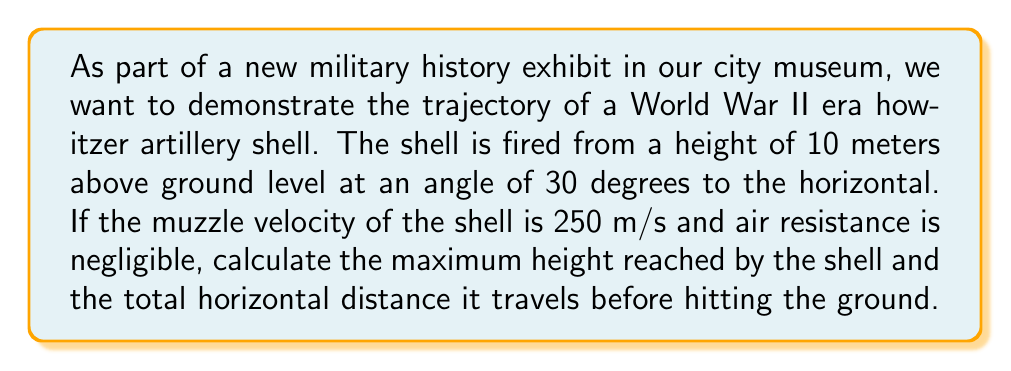Could you help me with this problem? Let's approach this problem step by step using projectile motion equations.

1) First, let's define our variables:
   $v_0 = 250$ m/s (initial velocity)
   $\theta = 30°$ (angle of projection)
   $g = 9.8$ m/s² (acceleration due to gravity)
   $y_0 = 10$ m (initial height)

2) We can break down the initial velocity into its horizontal and vertical components:
   $v_{0x} = v_0 \cos \theta = 250 \cos 30° = 250 \cdot \frac{\sqrt{3}}{2} \approx 216.51$ m/s
   $v_{0y} = v_0 \sin \theta = 250 \sin 30° = 250 \cdot \frac{1}{2} = 125$ m/s

3) To find the maximum height, we need to calculate the time it takes for the vertical velocity to become zero:
   $v_y = v_{0y} - gt$
   $0 = 125 - 9.8t$
   $t = \frac{125}{9.8} \approx 12.76$ seconds

4) Now we can calculate the maximum height using the equation:
   $y = y_0 + v_{0y}t - \frac{1}{2}gt^2$
   $y_{max} = 10 + 125 \cdot 12.76 - \frac{1}{2} \cdot 9.8 \cdot 12.76^2$
   $y_{max} = 10 + 1595 - 796.5 = 808.5$ meters

5) To find the total horizontal distance, we need to calculate the time it takes for the shell to hit the ground. We can use the quadratic formula with the vertical motion equation:
   $y = y_0 + v_{0y}t - \frac{1}{2}gt^2$
   $0 = 10 + 125t - 4.9t^2$
   $4.9t^2 - 125t - 10 = 0$

   Using the quadratic formula: $t = \frac{-b \pm \sqrt{b^2 - 4ac}}{2a}$
   $t = \frac{125 \pm \sqrt{125^2 + 4 \cdot 4.9 \cdot 10}}{2 \cdot 4.9} \approx 25.77$ seconds

6) Now we can calculate the horizontal distance:
   $x = v_{0x} \cdot t = 216.51 \cdot 25.77 \approx 5579.26$ meters

Therefore, the maximum height reached is approximately 808.5 meters, and the total horizontal distance traveled is approximately 5579.26 meters.
Answer: Maximum height: 808.5 meters
Total horizontal distance: 5579.26 meters 